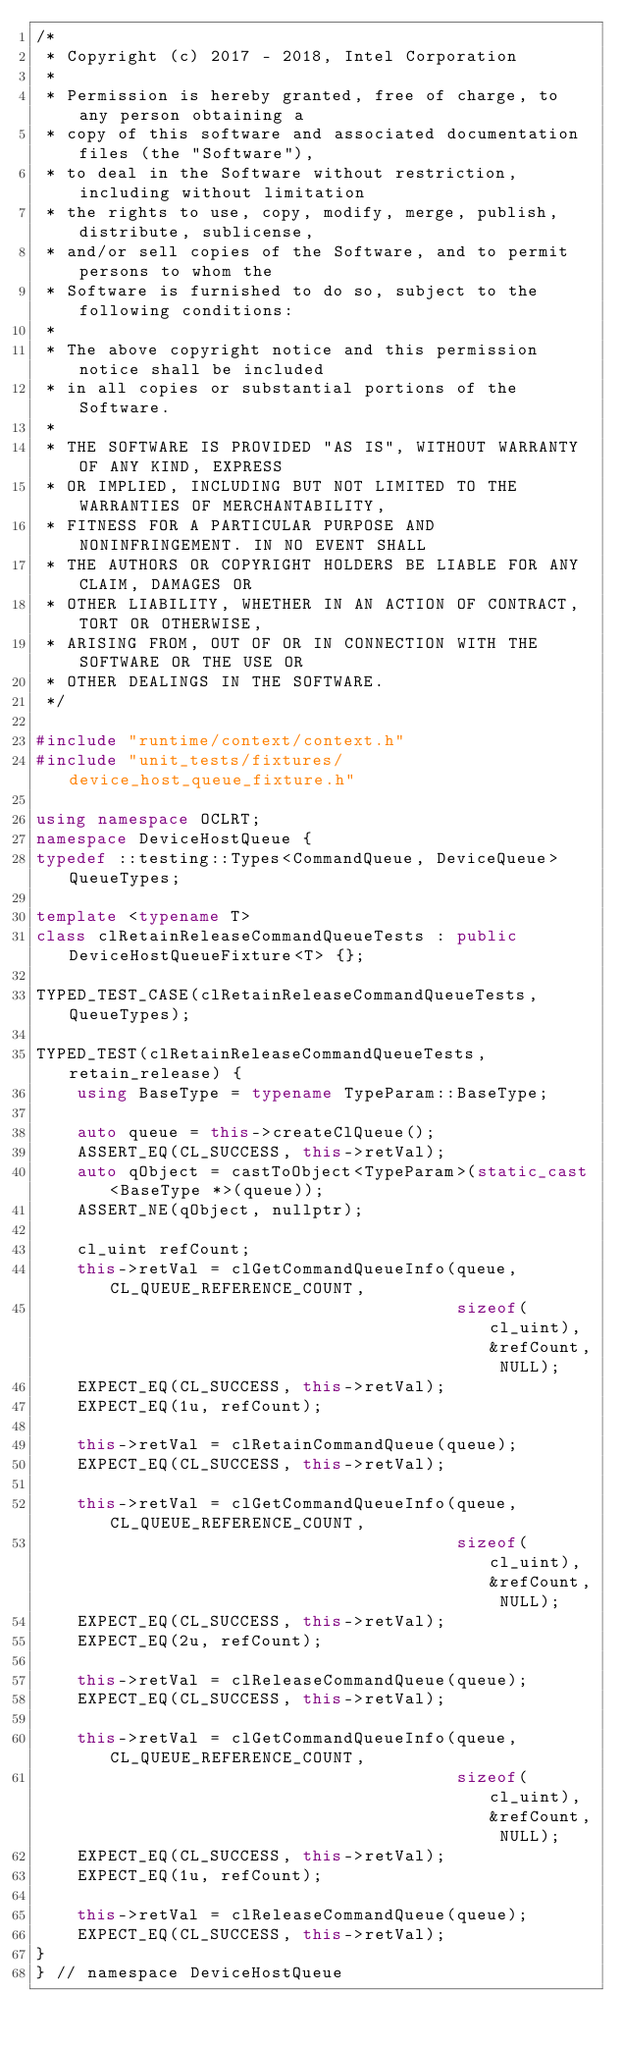<code> <loc_0><loc_0><loc_500><loc_500><_C++_>/*
 * Copyright (c) 2017 - 2018, Intel Corporation
 *
 * Permission is hereby granted, free of charge, to any person obtaining a
 * copy of this software and associated documentation files (the "Software"),
 * to deal in the Software without restriction, including without limitation
 * the rights to use, copy, modify, merge, publish, distribute, sublicense,
 * and/or sell copies of the Software, and to permit persons to whom the
 * Software is furnished to do so, subject to the following conditions:
 *
 * The above copyright notice and this permission notice shall be included
 * in all copies or substantial portions of the Software.
 *
 * THE SOFTWARE IS PROVIDED "AS IS", WITHOUT WARRANTY OF ANY KIND, EXPRESS
 * OR IMPLIED, INCLUDING BUT NOT LIMITED TO THE WARRANTIES OF MERCHANTABILITY,
 * FITNESS FOR A PARTICULAR PURPOSE AND NONINFRINGEMENT. IN NO EVENT SHALL
 * THE AUTHORS OR COPYRIGHT HOLDERS BE LIABLE FOR ANY CLAIM, DAMAGES OR
 * OTHER LIABILITY, WHETHER IN AN ACTION OF CONTRACT, TORT OR OTHERWISE,
 * ARISING FROM, OUT OF OR IN CONNECTION WITH THE SOFTWARE OR THE USE OR
 * OTHER DEALINGS IN THE SOFTWARE.
 */

#include "runtime/context/context.h"
#include "unit_tests/fixtures/device_host_queue_fixture.h"

using namespace OCLRT;
namespace DeviceHostQueue {
typedef ::testing::Types<CommandQueue, DeviceQueue> QueueTypes;

template <typename T>
class clRetainReleaseCommandQueueTests : public DeviceHostQueueFixture<T> {};

TYPED_TEST_CASE(clRetainReleaseCommandQueueTests, QueueTypes);

TYPED_TEST(clRetainReleaseCommandQueueTests, retain_release) {
    using BaseType = typename TypeParam::BaseType;

    auto queue = this->createClQueue();
    ASSERT_EQ(CL_SUCCESS, this->retVal);
    auto qObject = castToObject<TypeParam>(static_cast<BaseType *>(queue));
    ASSERT_NE(qObject, nullptr);

    cl_uint refCount;
    this->retVal = clGetCommandQueueInfo(queue, CL_QUEUE_REFERENCE_COUNT,
                                         sizeof(cl_uint), &refCount, NULL);
    EXPECT_EQ(CL_SUCCESS, this->retVal);
    EXPECT_EQ(1u, refCount);

    this->retVal = clRetainCommandQueue(queue);
    EXPECT_EQ(CL_SUCCESS, this->retVal);

    this->retVal = clGetCommandQueueInfo(queue, CL_QUEUE_REFERENCE_COUNT,
                                         sizeof(cl_uint), &refCount, NULL);
    EXPECT_EQ(CL_SUCCESS, this->retVal);
    EXPECT_EQ(2u, refCount);

    this->retVal = clReleaseCommandQueue(queue);
    EXPECT_EQ(CL_SUCCESS, this->retVal);

    this->retVal = clGetCommandQueueInfo(queue, CL_QUEUE_REFERENCE_COUNT,
                                         sizeof(cl_uint), &refCount, NULL);
    EXPECT_EQ(CL_SUCCESS, this->retVal);
    EXPECT_EQ(1u, refCount);

    this->retVal = clReleaseCommandQueue(queue);
    EXPECT_EQ(CL_SUCCESS, this->retVal);
}
} // namespace DeviceHostQueue
</code> 